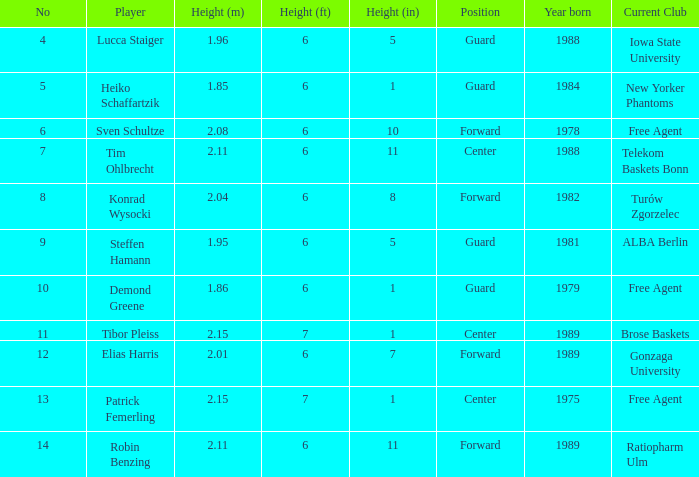Parse the full table. {'header': ['No', 'Player', 'Height (m)', 'Height (ft)', 'Height (in)', 'Position', 'Year born', 'Current Club'], 'rows': [['4', 'Lucca Staiger', '1.96', '6', '5', 'Guard', '1988', 'Iowa State University'], ['5', 'Heiko Schaffartzik', '1.85', '6', '1', 'Guard', '1984', 'New Yorker Phantoms'], ['6', 'Sven Schultze', '2.08', '6', '10', 'Forward', '1978', 'Free Agent'], ['7', 'Tim Ohlbrecht', '2.11', '6', '11', 'Center', '1988', 'Telekom Baskets Bonn'], ['8', 'Konrad Wysocki', '2.04', '6', '8', 'Forward', '1982', 'Turów Zgorzelec'], ['9', 'Steffen Hamann', '1.95', '6', '5', 'Guard', '1981', 'ALBA Berlin'], ['10', 'Demond Greene', '1.86', '6', '1', 'Guard', '1979', 'Free Agent'], ['11', 'Tibor Pleiss', '2.15', '7', '1', 'Center', '1989', 'Brose Baskets'], ['12', 'Elias Harris', '2.01', '6', '7', 'Forward', '1989', 'Gonzaga University'], ['13', 'Patrick Femerling', '2.15', '7', '1', 'Center', '1975', 'Free Agent'], ['14', 'Robin Benzing', '2.11', '6', '11', 'Forward', '1989', 'Ratiopharm Ulm']]} Name the height for steffen hamann 6' 05". 